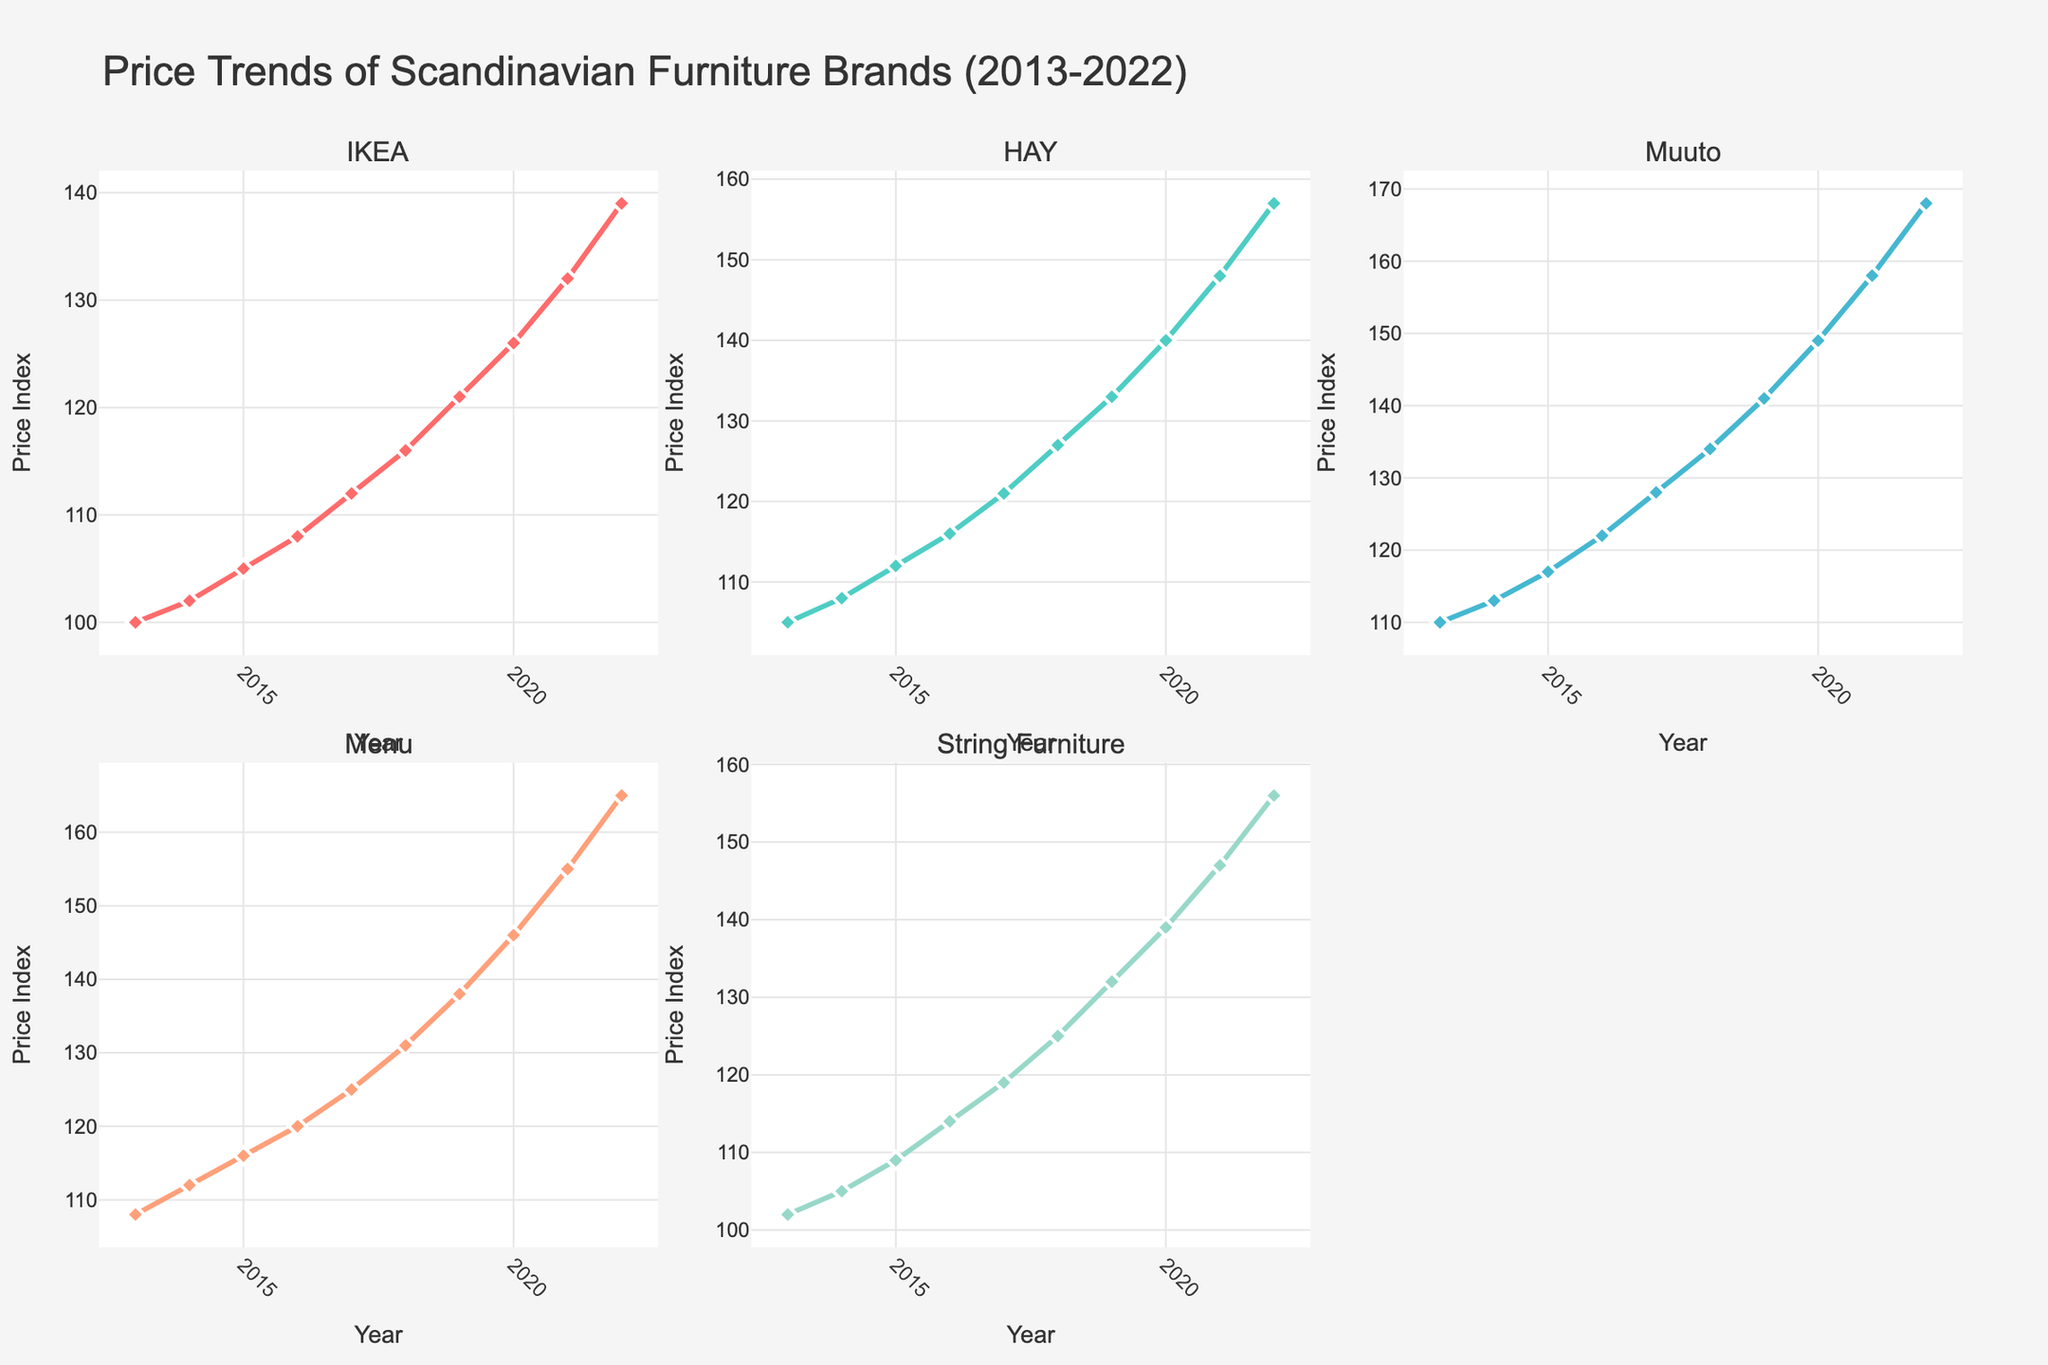What is the title of the figure? The title is located at the top center of the figure. It provides a summary of what the figure represents. In this case, it reads "Price Trends of Scandinavian Furniture Brands (2013-2022)."
Answer: Price Trends of Scandinavian Furniture Brands (2013-2022) How many brands are depicted in the figure? By counting the subplot titles or the different lines, we can see there are five brands represented.
Answer: Five What is the price index for IKEA in 2017? Locate the IKEA subplot, find the year 2017 on the x-axis, and trace upwards to the corresponding line, which shows a price index of 112.
Answer: 112 Which brand experienced the highest price increase from 2019 to 2020? By looking at the difference in values between 2019 and 2020 for all brands: IKEA (121 to 126), HAY (133 to 140), Muuto (141 to 149), Menu (138 to 146), and String Furniture (132 to 139), Muuto has the highest increase (8 units).
Answer: Muuto What was the average price index of HAY over the decade? Sum the yearly price indices for HAY from 2013 to 2022 (105, 108, 112, 116, 121, 127, 133, 140, 148, 157), which equals 1167, then divide by the number of years (10).
Answer: 116.7 Which two brands showed parallel trends from 2015 to 2018? By comparing the lines for each brand from 2015 to 2018, IKEA and HAY both show similarly shaped curves, indicating parallel trends.
Answer: IKEA and HAY In which year did Menu's price index first surpass 150? Trace the Menu line to see when it first crosses the y-axis value of 150, which occurs in 2020.
Answer: 2020 What is the largest price index difference between two brands in 2022? Check the 2022 price indices for all brands: IKEA (139), HAY (157), Muuto (168), Menu (165), String Furniture (156). The largest difference is between IKEA and Muuto (168 - 139 = 29).
Answer: 29 Did any brand have a constant increase in price index every year? By checking the trend lines for each brand, they all show a steady increase without any drop or fluctuation year-on-year.
Answer: Yes How does the trend for String Furniture compare to Menu from 2019 to 2022? From 2019 to 2022, trace both String Furniture (132, 139, 147, 156) and Menu (138, 146, 155, 165). Both show an upward trend, but Menu consistently has higher values and increases slightly more rapidly.
Answer: Menu increases more rapidly and has higher values 